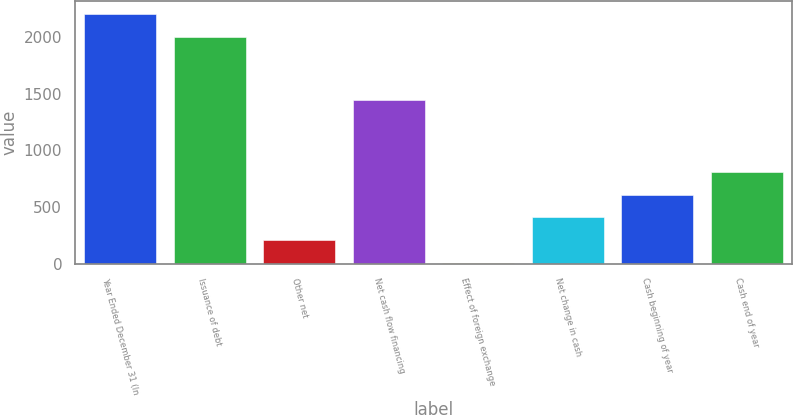<chart> <loc_0><loc_0><loc_500><loc_500><bar_chart><fcel>Year Ended December 31 (In<fcel>Issuance of debt<fcel>Other net<fcel>Net cash flow financing<fcel>Effect of foreign exchange<fcel>Net change in cash<fcel>Cash beginning of year<fcel>Cash end of year<nl><fcel>2204.6<fcel>2004<fcel>208.6<fcel>1442<fcel>8<fcel>409.2<fcel>609.8<fcel>810.4<nl></chart> 